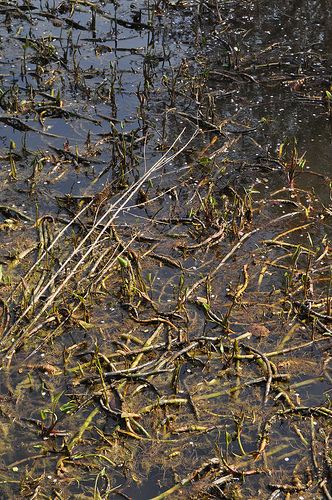<image>
Is the stick above the grass? Yes. The stick is positioned above the grass in the vertical space, higher up in the scene. 